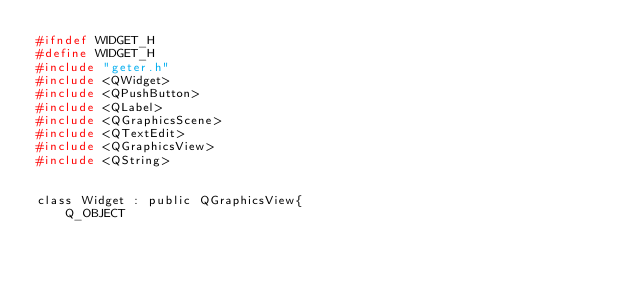Convert code to text. <code><loc_0><loc_0><loc_500><loc_500><_C_>#ifndef WIDGET_H
#define WIDGET_H
#include "geter.h"
#include <QWidget>
#include <QPushButton>
#include <QLabel>
#include <QGraphicsScene>
#include <QTextEdit>
#include <QGraphicsView>
#include <QString>


class Widget : public QGraphicsView{
    Q_OBJECT</code> 